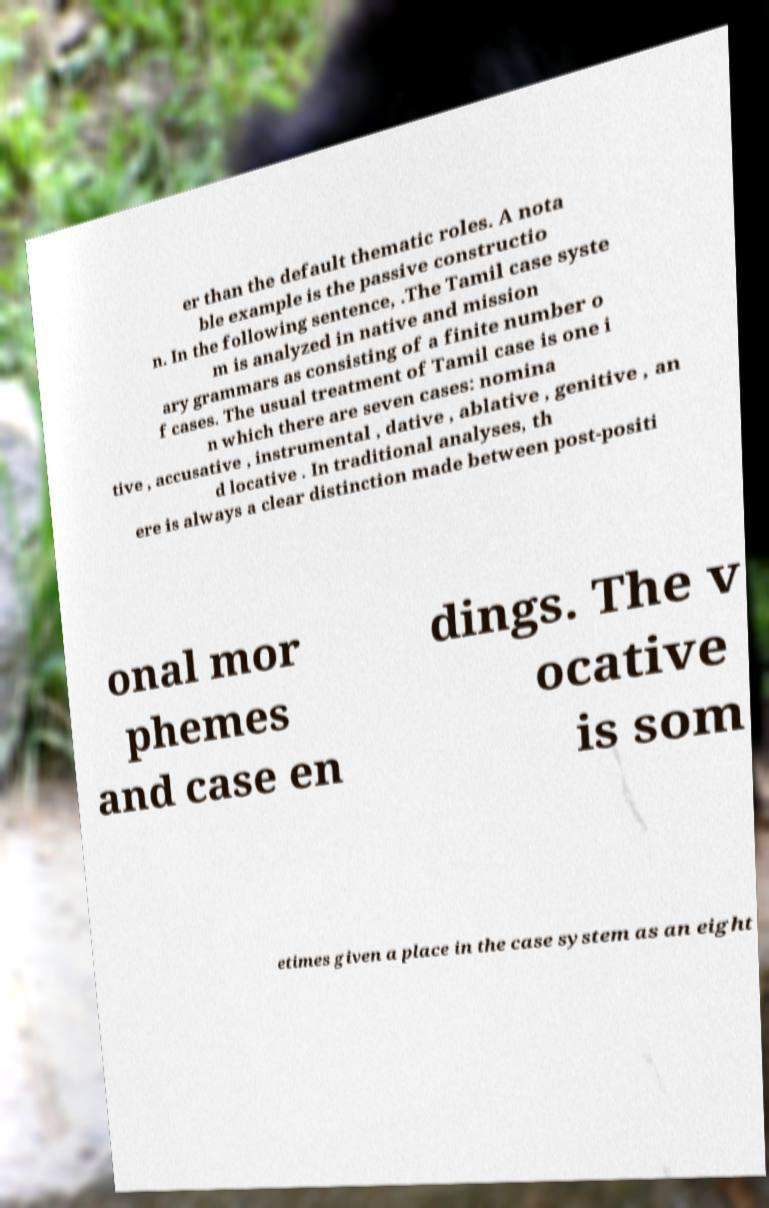Please identify and transcribe the text found in this image. er than the default thematic roles. A nota ble example is the passive constructio n. In the following sentence, .The Tamil case syste m is analyzed in native and mission ary grammars as consisting of a finite number o f cases. The usual treatment of Tamil case is one i n which there are seven cases: nomina tive , accusative , instrumental , dative , ablative , genitive , an d locative . In traditional analyses, th ere is always a clear distinction made between post-positi onal mor phemes and case en dings. The v ocative is som etimes given a place in the case system as an eight 